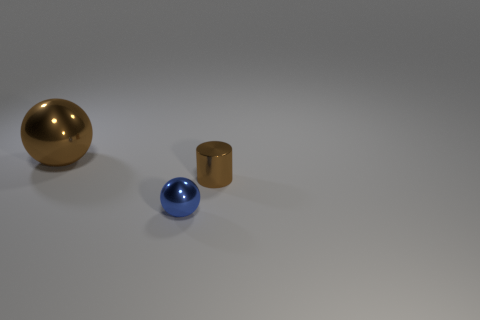Can you describe the materials of the objects shown? Certainly! In the image, there appear to be three objects, each with a different material finish. The ball on the far left has a reflective golden finish, indicative of a polished metal surface. The blue sphere in the center has a glossy appearance, suggesting it could be made of glass or a highly polished coated metal. Lastly, the cylinder on the right also appears to have a metallic finish, similar to the golden ball, but with a distinct, possibly bronzed tone. 